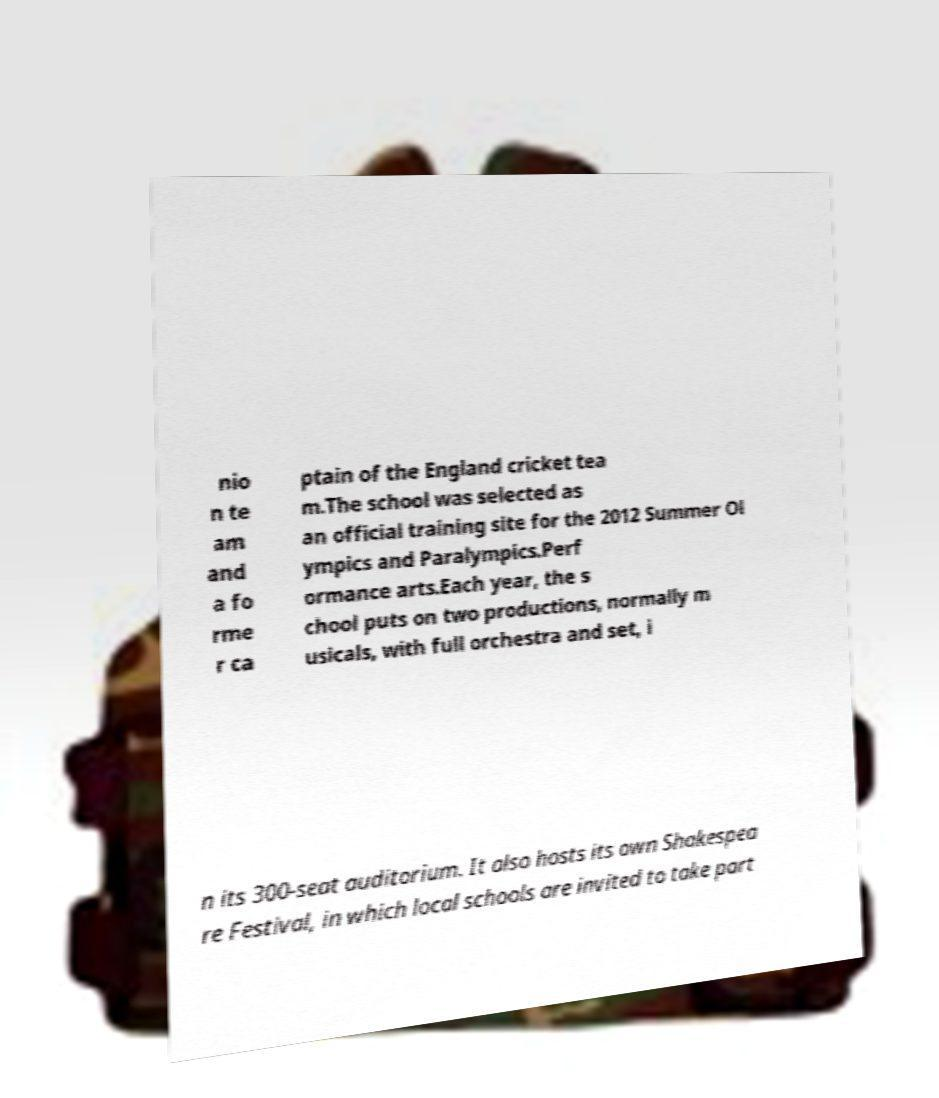What messages or text are displayed in this image? I need them in a readable, typed format. nio n te am and a fo rme r ca ptain of the England cricket tea m.The school was selected as an official training site for the 2012 Summer Ol ympics and Paralympics.Perf ormance arts.Each year, the s chool puts on two productions, normally m usicals, with full orchestra and set, i n its 300-seat auditorium. It also hosts its own Shakespea re Festival, in which local schools are invited to take part 